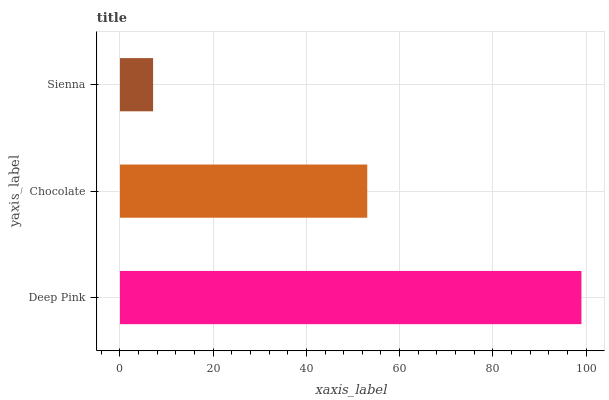Is Sienna the minimum?
Answer yes or no. Yes. Is Deep Pink the maximum?
Answer yes or no. Yes. Is Chocolate the minimum?
Answer yes or no. No. Is Chocolate the maximum?
Answer yes or no. No. Is Deep Pink greater than Chocolate?
Answer yes or no. Yes. Is Chocolate less than Deep Pink?
Answer yes or no. Yes. Is Chocolate greater than Deep Pink?
Answer yes or no. No. Is Deep Pink less than Chocolate?
Answer yes or no. No. Is Chocolate the high median?
Answer yes or no. Yes. Is Chocolate the low median?
Answer yes or no. Yes. Is Deep Pink the high median?
Answer yes or no. No. Is Deep Pink the low median?
Answer yes or no. No. 